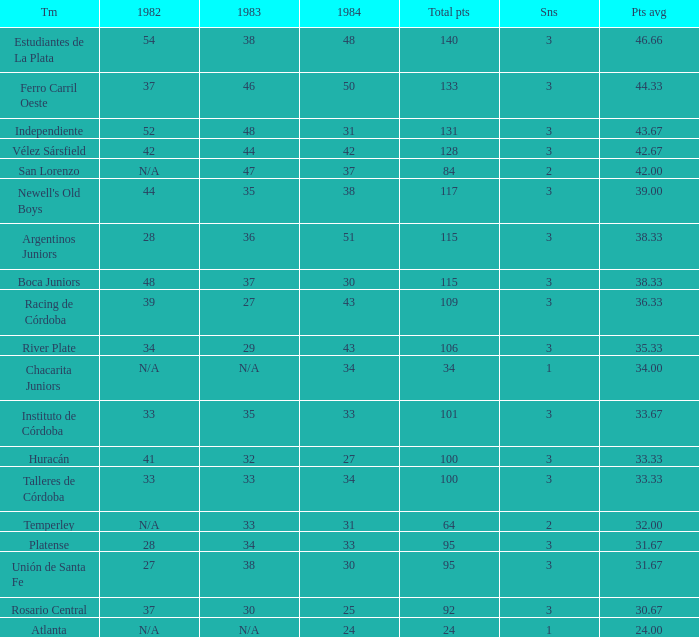What is the number of seasons for the team with a total fewer than 24? None. 